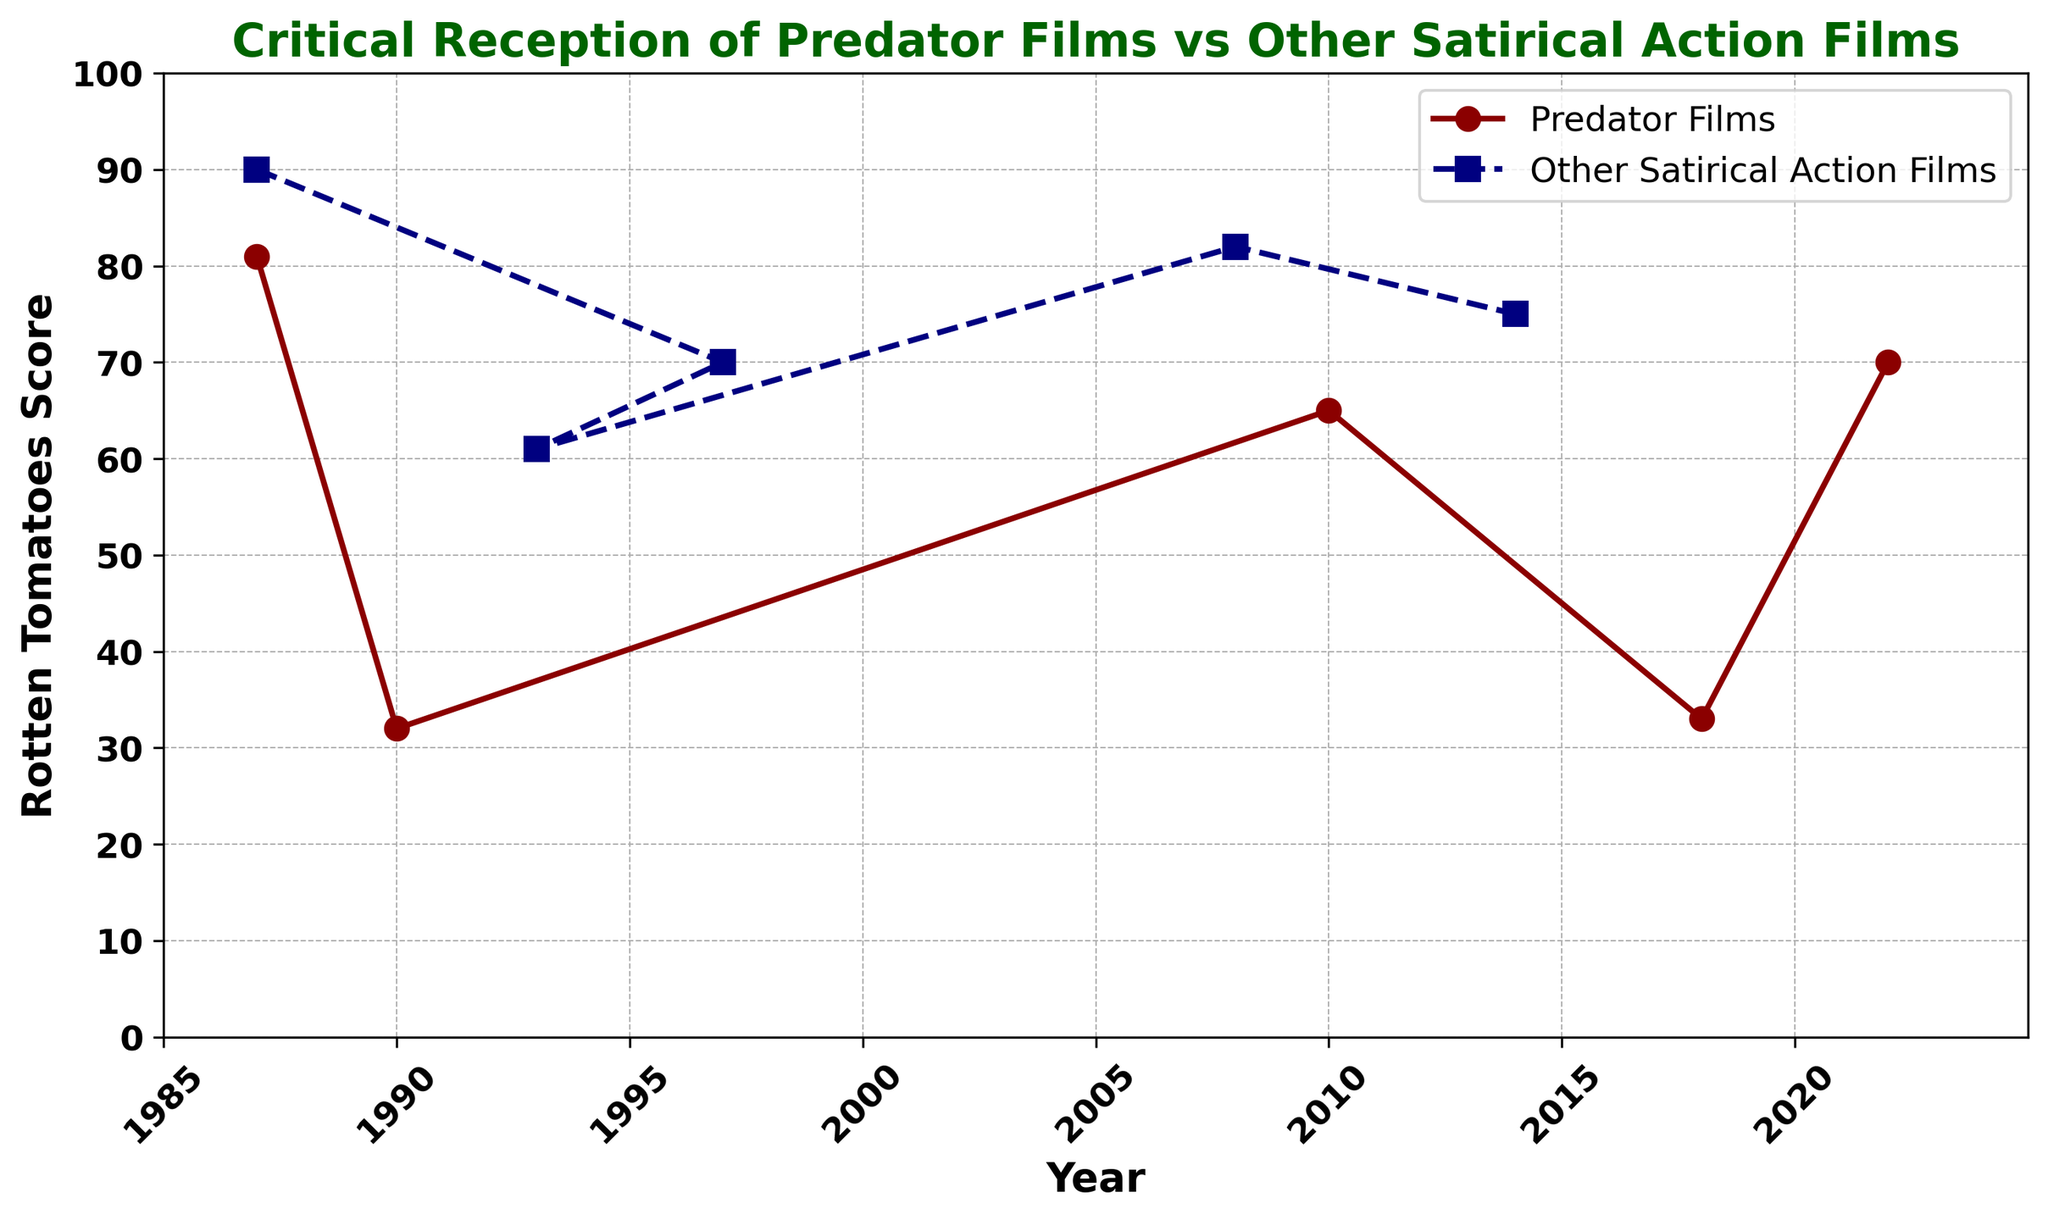What year had the highest Rotten Tomatoes score for Predator films? Looking at the plot for the red line representing Predator films, the highest point is in 1987 with the movie "Predator."
Answer: 1987 Which movie has a higher Rotten Tomatoes score: "Predator" (1987) or "Tropic Thunder" (2008)? Compare the points on the red line for "Predator" in 1987 and the navy line for "Tropic Thunder" in 2008. "Predator" has a score of 81, while "Tropic Thunder" has a score of 82.
Answer: Tropic Thunder What is the average Rotten Tomatoes score of all Predator films? The Rotten Tomatoes scores for all Predator films are 81, 32, 65, 33, and 70. The average is calculated as (81 + 32 + 65 + 33 + 70) / 5 = 56.2.
Answer: 56.2 How does the Rotten Tomatoes score of "The Predator" (2018) compare to that of "Predator 2" (1990)? Comparing the red points for 2018 and 1990 on the plot, "The Predator" has a score of 33, while "Predator 2" has a score of 32.
Answer: The Predator (2018) is slightly higher Which non-Predator film had the highest Rotten Tomatoes score, and what year was it released? Looking at the highest point on the navy line, "RoboCop" in 1987 had the highest score with 90.
Answer: RoboCop (1987) What is the median Rotten Tomatoes score of the non-Predator films? The scores are 90, 70, 61, 82, and 75. Sorting these: 61, 70, 75, 82, 90. The median score, being the middle value, is 75.
Answer: 75 Which had a better average score: Predator films or non-Predator films? The average score for Predator films is 56.2. The Rotten Tomatoes scores for non-Predator films are 90, 70, 61, 82, and 75, with an average = (90 + 70 + 61 + 82 + 75) / 5 = 75.6.
Answer: Non-Predator films From 1987 to 2022, which film has the lowest Rotten Tomatoes score and what is it? The lowest point on the entire plot, which includes both lines, is for "Predator 2" in 1990 with a score of 32.
Answer: Predator 2 How did the critical reception of Predator films change from "Predator" (1987) to "Predator (2022)"? Comparing the points on the red line from 1987 to 2022, "Predator" in 1987 had a score of 81, and "Predator (2022)" had a score of 70. Therefore, there was a decline but slight recovery compared to mid-points.
Answer: Declined then slightly recovered 